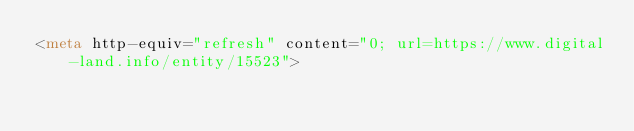<code> <loc_0><loc_0><loc_500><loc_500><_HTML_><meta http-equiv="refresh" content="0; url=https://www.digital-land.info/entity/15523"></code> 